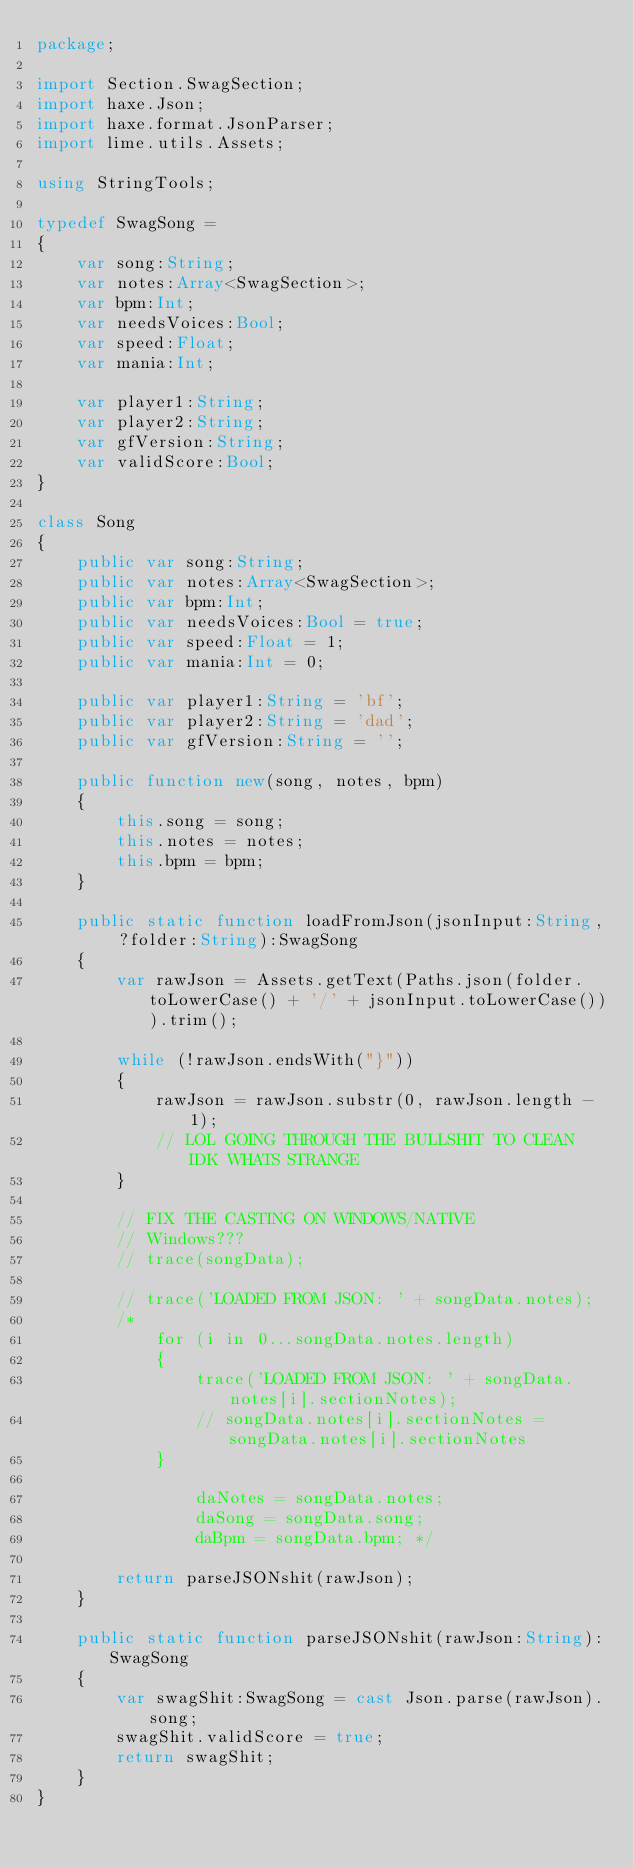Convert code to text. <code><loc_0><loc_0><loc_500><loc_500><_Haxe_>package;

import Section.SwagSection;
import haxe.Json;
import haxe.format.JsonParser;
import lime.utils.Assets;

using StringTools;

typedef SwagSong =
{
	var song:String;
	var notes:Array<SwagSection>;
	var bpm:Int;
	var needsVoices:Bool;
	var speed:Float;
	var mania:Int;

	var player1:String;
	var player2:String;
	var gfVersion:String;
	var validScore:Bool;
}

class Song
{
	public var song:String;
	public var notes:Array<SwagSection>;
	public var bpm:Int;
	public var needsVoices:Bool = true;
	public var speed:Float = 1;
	public var mania:Int = 0;

	public var player1:String = 'bf';
	public var player2:String = 'dad';
	public var gfVersion:String = '';

	public function new(song, notes, bpm)
	{
		this.song = song;
		this.notes = notes;
		this.bpm = bpm;
	}

	public static function loadFromJson(jsonInput:String, ?folder:String):SwagSong
	{
		var rawJson = Assets.getText(Paths.json(folder.toLowerCase() + '/' + jsonInput.toLowerCase())).trim();

		while (!rawJson.endsWith("}"))
		{
			rawJson = rawJson.substr(0, rawJson.length - 1);
			// LOL GOING THROUGH THE BULLSHIT TO CLEAN IDK WHATS STRANGE
		}

		// FIX THE CASTING ON WINDOWS/NATIVE
		// Windows???
		// trace(songData);

		// trace('LOADED FROM JSON: ' + songData.notes);
		/* 
			for (i in 0...songData.notes.length)
			{
				trace('LOADED FROM JSON: ' + songData.notes[i].sectionNotes);
				// songData.notes[i].sectionNotes = songData.notes[i].sectionNotes
			}

				daNotes = songData.notes;
				daSong = songData.song;
				daBpm = songData.bpm; */

		return parseJSONshit(rawJson);
	}

	public static function parseJSONshit(rawJson:String):SwagSong
	{
		var swagShit:SwagSong = cast Json.parse(rawJson).song;
		swagShit.validScore = true;
		return swagShit;
	}
}
</code> 